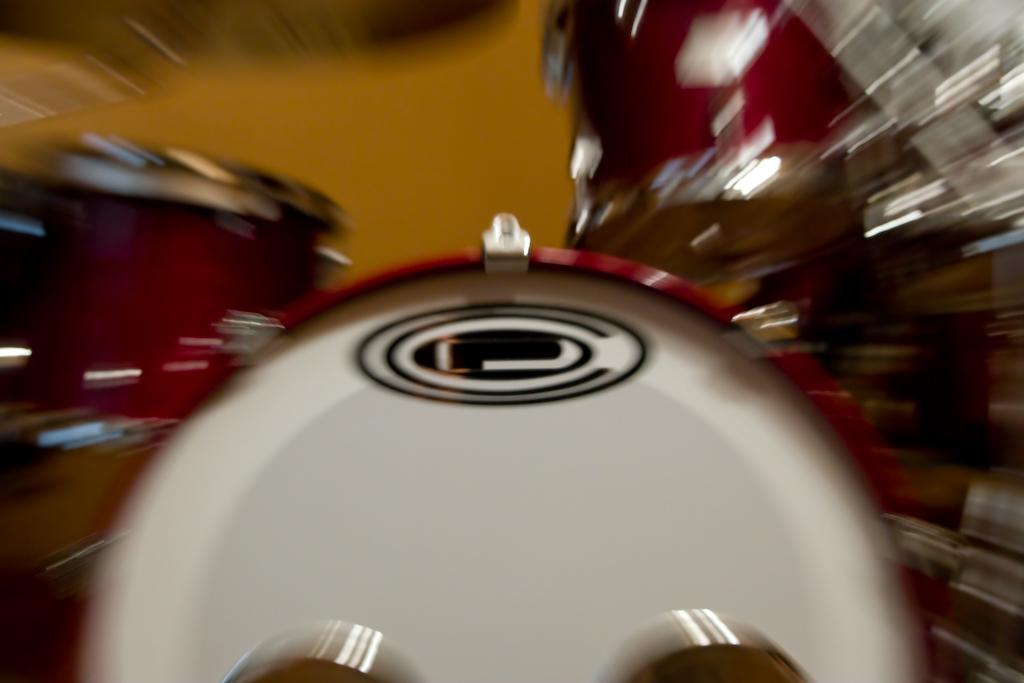What type of objects can be seen in the image? There are musical instruments in the image. Can you describe the musical instruments in more detail? Unfortunately, the provided facts do not give any specific details about the musical instruments. How many musical instruments are visible in the image? The number of musical instruments cannot be determined from the given facts. What type of cream is being used to lubricate the form in the image? There is no form or cream present in the image; it only features musical instruments. 